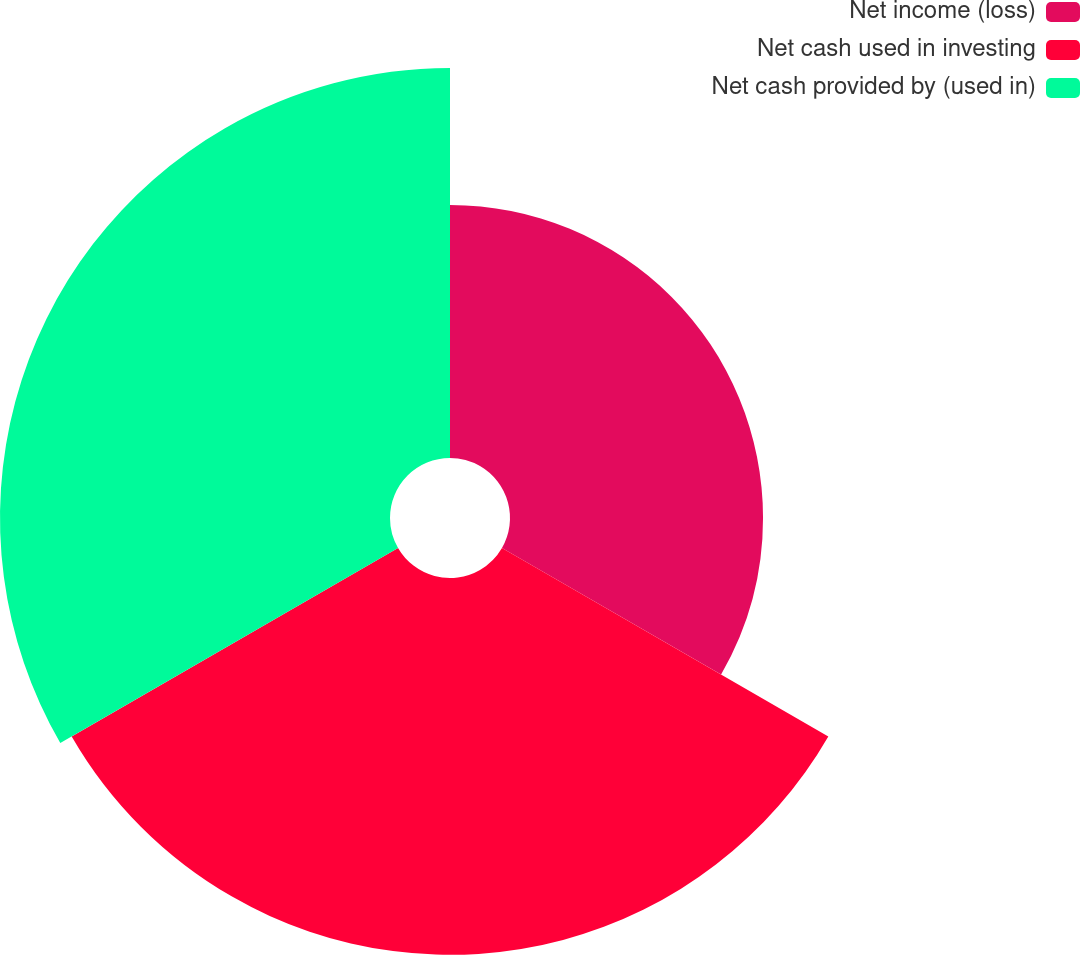Convert chart. <chart><loc_0><loc_0><loc_500><loc_500><pie_chart><fcel>Net income (loss)<fcel>Net cash used in investing<fcel>Net cash provided by (used in)<nl><fcel>24.81%<fcel>36.95%<fcel>38.24%<nl></chart> 